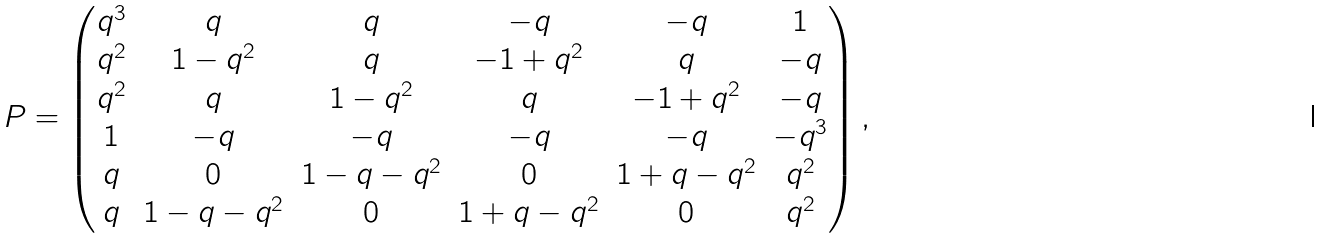<formula> <loc_0><loc_0><loc_500><loc_500>P = \begin{pmatrix} q ^ { 3 } & q & q & - q & - q & 1 \\ q ^ { 2 } & 1 - q ^ { 2 } & q & - 1 + q ^ { 2 } & q & - q \\ q ^ { 2 } & q & 1 - q ^ { 2 } & q & - 1 + q ^ { 2 } & - q \\ 1 & - q & - q & - q & - q & - q ^ { 3 } \\ q & 0 & 1 - q - q ^ { 2 } & 0 & 1 + q - q ^ { 2 } & q ^ { 2 } \\ q & 1 - q - q ^ { 2 } & 0 & 1 + q - q ^ { 2 } & 0 & q ^ { 2 } \end{pmatrix} ,</formula> 